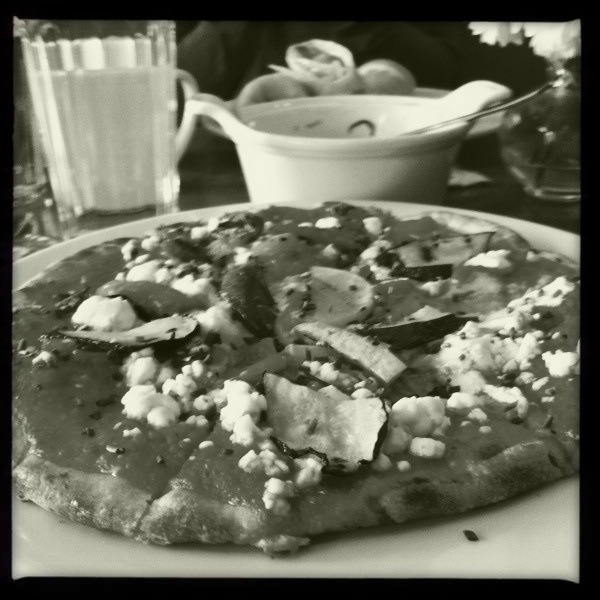Describe the objects in this image and their specific colors. I can see pizza in black, gray, darkgreen, and darkgray tones, cup in black, darkgray, beige, lightgray, and gray tones, cup in black, beige, darkgray, lightgray, and gray tones, bowl in black, beige, darkgray, and lightgray tones, and vase in black, darkgreen, gray, and darkgray tones in this image. 